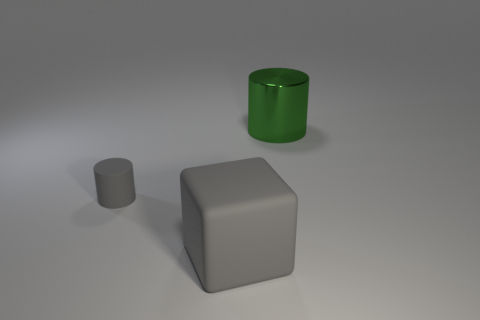What number of other objects are there of the same material as the green cylinder?
Keep it short and to the point. 0. Are there fewer small red rubber cylinders than matte things?
Offer a very short reply. Yes. Are the big cylinder and the object in front of the small cylinder made of the same material?
Your answer should be very brief. No. What shape is the big thing left of the green object?
Give a very brief answer. Cube. Is there any other thing of the same color as the cube?
Offer a terse response. Yes. Is the number of large green cylinders on the left side of the green metal cylinder less than the number of big red rubber things?
Give a very brief answer. No. How many other rubber things have the same size as the green object?
Your answer should be compact. 1. The other thing that is the same color as the big rubber thing is what shape?
Your response must be concise. Cylinder. What is the shape of the gray rubber thing that is to the left of the thing in front of the cylinder that is in front of the big green cylinder?
Make the answer very short. Cylinder. What is the color of the cylinder that is left of the big gray thing?
Your response must be concise. Gray. 